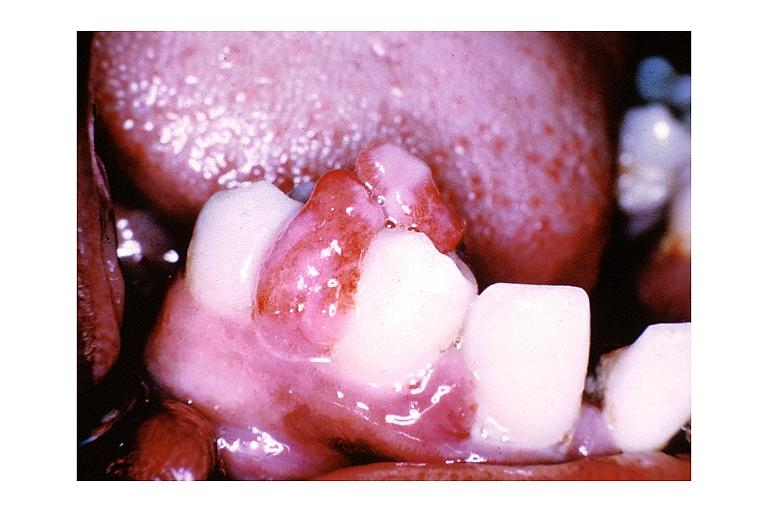s oral present?
Answer the question using a single word or phrase. Yes 